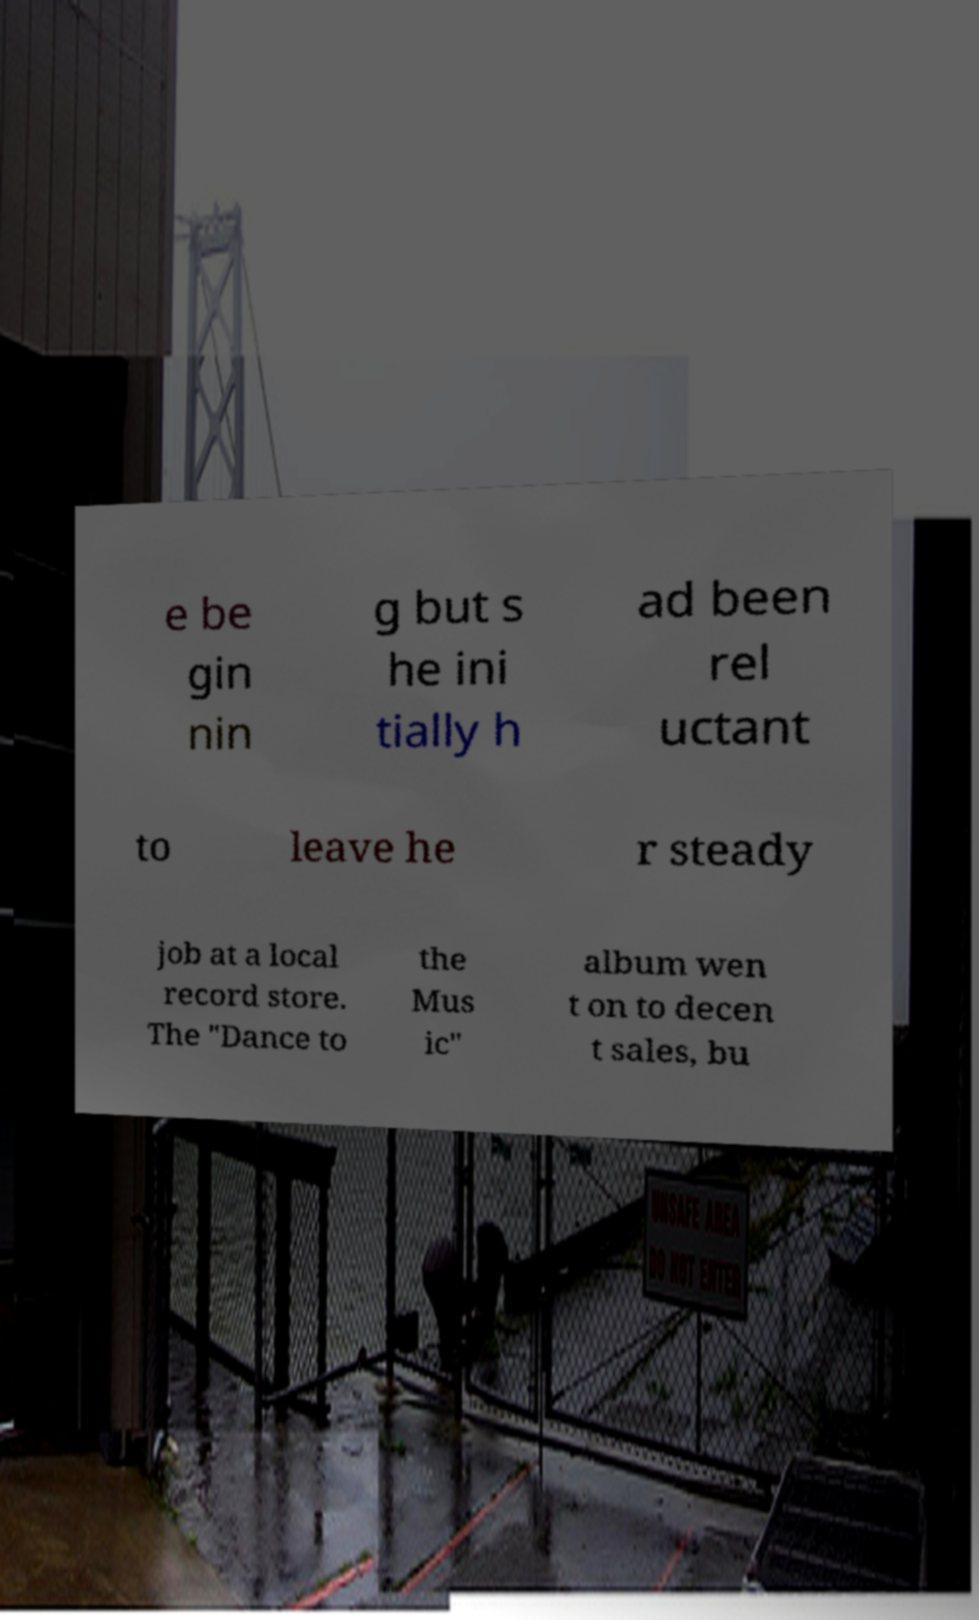There's text embedded in this image that I need extracted. Can you transcribe it verbatim? e be gin nin g but s he ini tially h ad been rel uctant to leave he r steady job at a local record store. The "Dance to the Mus ic" album wen t on to decen t sales, bu 